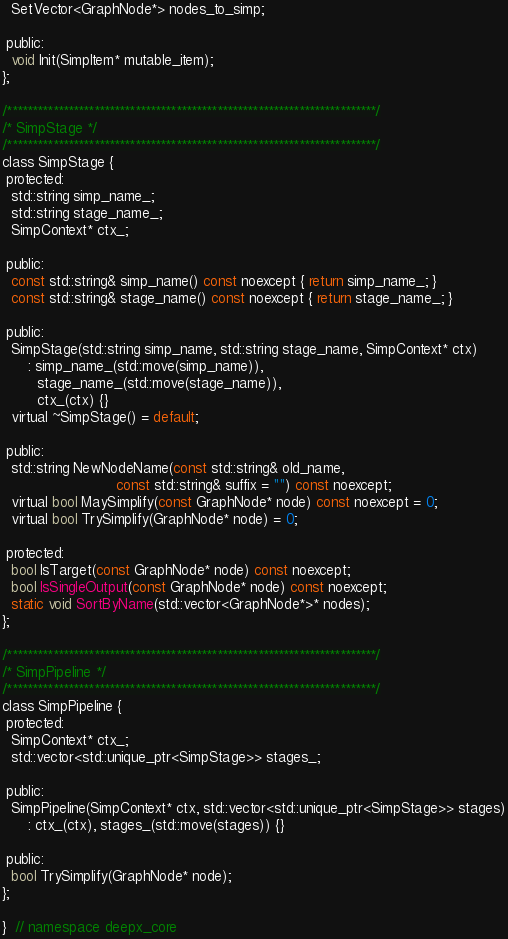Convert code to text. <code><loc_0><loc_0><loc_500><loc_500><_C_>  SetVector<GraphNode*> nodes_to_simp;

 public:
  void Init(SimpItem* mutable_item);
};

/************************************************************************/
/* SimpStage */
/************************************************************************/
class SimpStage {
 protected:
  std::string simp_name_;
  std::string stage_name_;
  SimpContext* ctx_;

 public:
  const std::string& simp_name() const noexcept { return simp_name_; }
  const std::string& stage_name() const noexcept { return stage_name_; }

 public:
  SimpStage(std::string simp_name, std::string stage_name, SimpContext* ctx)
      : simp_name_(std::move(simp_name)),
        stage_name_(std::move(stage_name)),
        ctx_(ctx) {}
  virtual ~SimpStage() = default;

 public:
  std::string NewNodeName(const std::string& old_name,
                          const std::string& suffix = "") const noexcept;
  virtual bool MaySimplify(const GraphNode* node) const noexcept = 0;
  virtual bool TrySimplify(GraphNode* node) = 0;

 protected:
  bool IsTarget(const GraphNode* node) const noexcept;
  bool IsSingleOutput(const GraphNode* node) const noexcept;
  static void SortByName(std::vector<GraphNode*>* nodes);
};

/************************************************************************/
/* SimpPipeline */
/************************************************************************/
class SimpPipeline {
 protected:
  SimpContext* ctx_;
  std::vector<std::unique_ptr<SimpStage>> stages_;

 public:
  SimpPipeline(SimpContext* ctx, std::vector<std::unique_ptr<SimpStage>> stages)
      : ctx_(ctx), stages_(std::move(stages)) {}

 public:
  bool TrySimplify(GraphNode* node);
};

}  // namespace deepx_core
</code> 